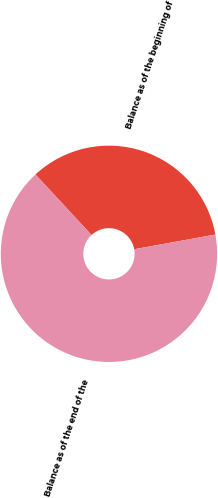Convert chart to OTSL. <chart><loc_0><loc_0><loc_500><loc_500><pie_chart><fcel>Balance as of the beginning of<fcel>Balance as of the end of the<nl><fcel>34.04%<fcel>65.96%<nl></chart> 